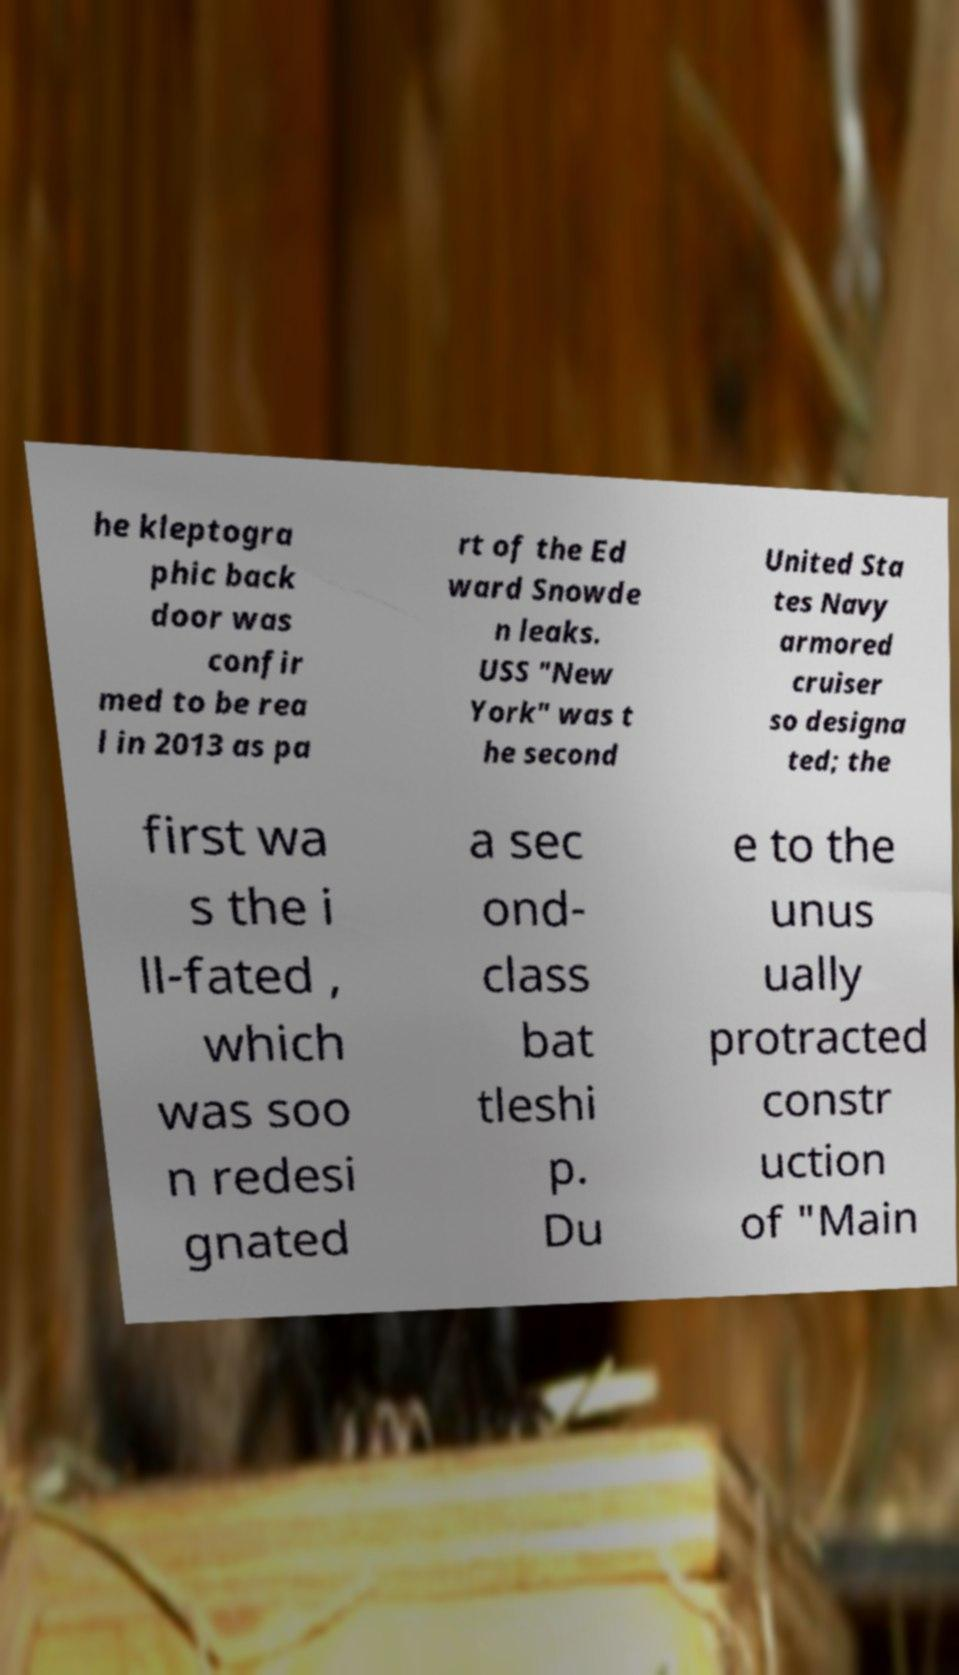There's text embedded in this image that I need extracted. Can you transcribe it verbatim? he kleptogra phic back door was confir med to be rea l in 2013 as pa rt of the Ed ward Snowde n leaks. USS "New York" was t he second United Sta tes Navy armored cruiser so designa ted; the first wa s the i ll-fated , which was soo n redesi gnated a sec ond- class bat tleshi p. Du e to the unus ually protracted constr uction of "Main 